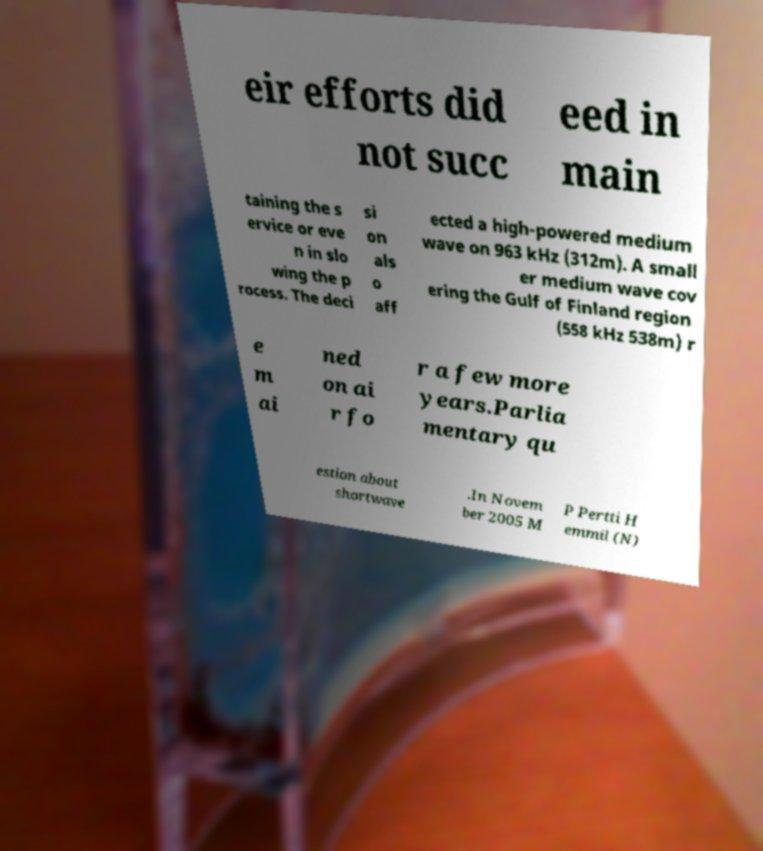Could you extract and type out the text from this image? eir efforts did not succ eed in main taining the s ervice or eve n in slo wing the p rocess. The deci si on als o aff ected a high-powered medium wave on 963 kHz (312m). A small er medium wave cov ering the Gulf of Finland region (558 kHz 538m) r e m ai ned on ai r fo r a few more years.Parlia mentary qu estion about shortwave .In Novem ber 2005 M P Pertti H emmil (N) 